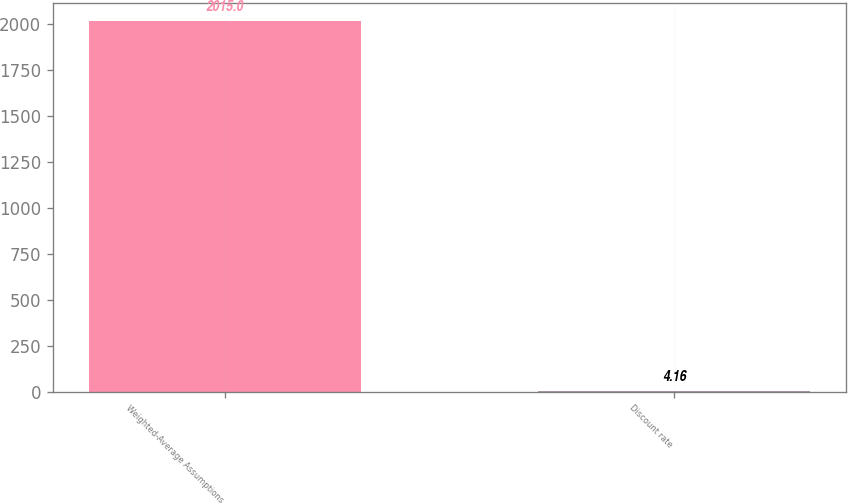Convert chart. <chart><loc_0><loc_0><loc_500><loc_500><bar_chart><fcel>Weighted-Average Assumptions<fcel>Discount rate<nl><fcel>2015<fcel>4.16<nl></chart> 